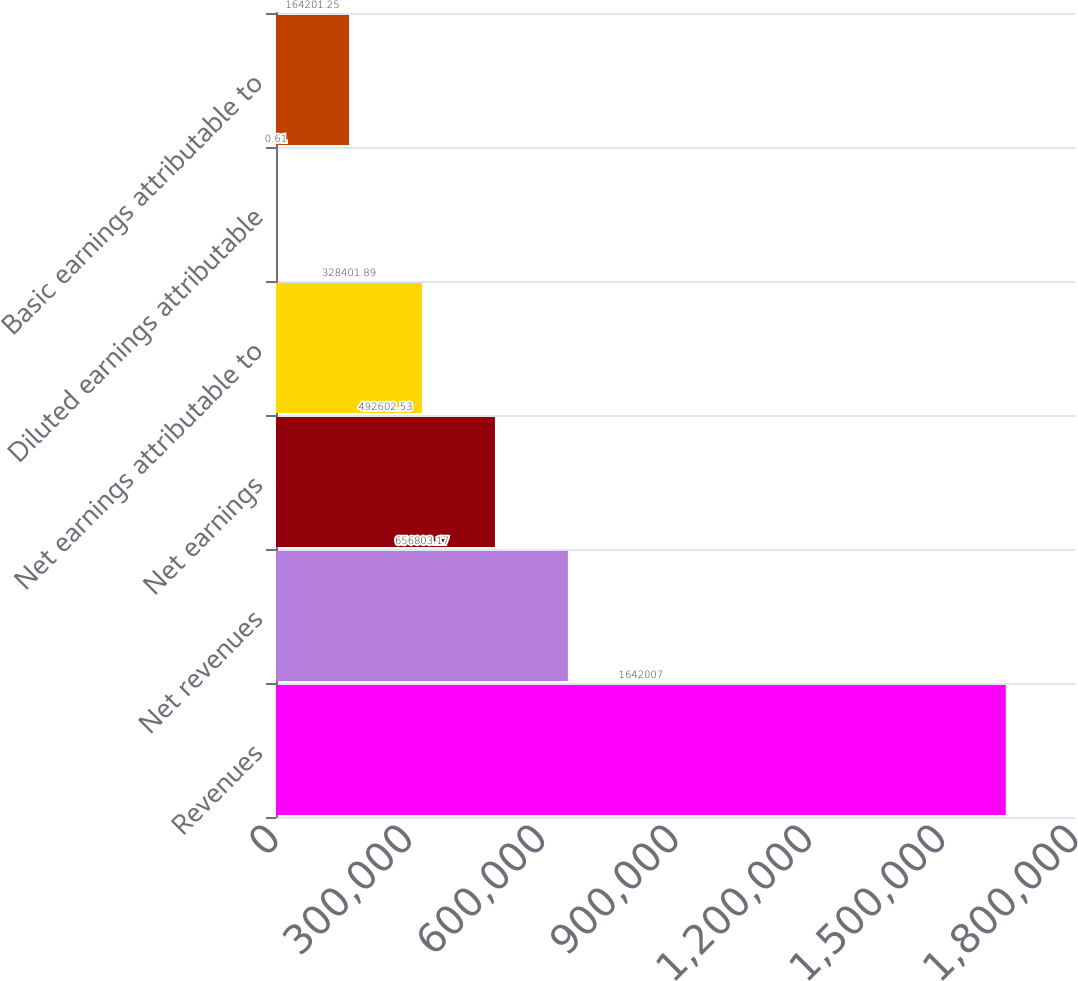Convert chart. <chart><loc_0><loc_0><loc_500><loc_500><bar_chart><fcel>Revenues<fcel>Net revenues<fcel>Net earnings<fcel>Net earnings attributable to<fcel>Diluted earnings attributable<fcel>Basic earnings attributable to<nl><fcel>1.64201e+06<fcel>656803<fcel>492603<fcel>328402<fcel>0.61<fcel>164201<nl></chart> 